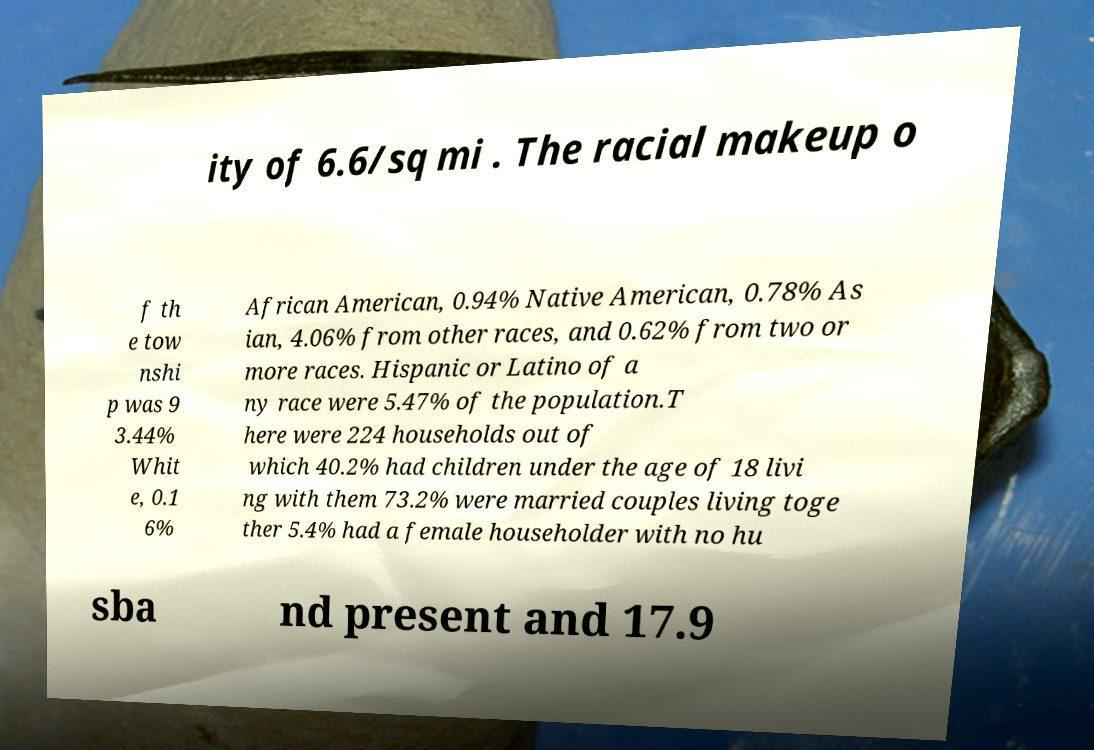I need the written content from this picture converted into text. Can you do that? ity of 6.6/sq mi . The racial makeup o f th e tow nshi p was 9 3.44% Whit e, 0.1 6% African American, 0.94% Native American, 0.78% As ian, 4.06% from other races, and 0.62% from two or more races. Hispanic or Latino of a ny race were 5.47% of the population.T here were 224 households out of which 40.2% had children under the age of 18 livi ng with them 73.2% were married couples living toge ther 5.4% had a female householder with no hu sba nd present and 17.9 